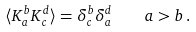Convert formula to latex. <formula><loc_0><loc_0><loc_500><loc_500>\langle K ^ { b } _ { a } K _ { c } ^ { d } \rangle = \delta _ { c } ^ { b } \delta _ { a } ^ { d } \quad a > b \, .</formula> 